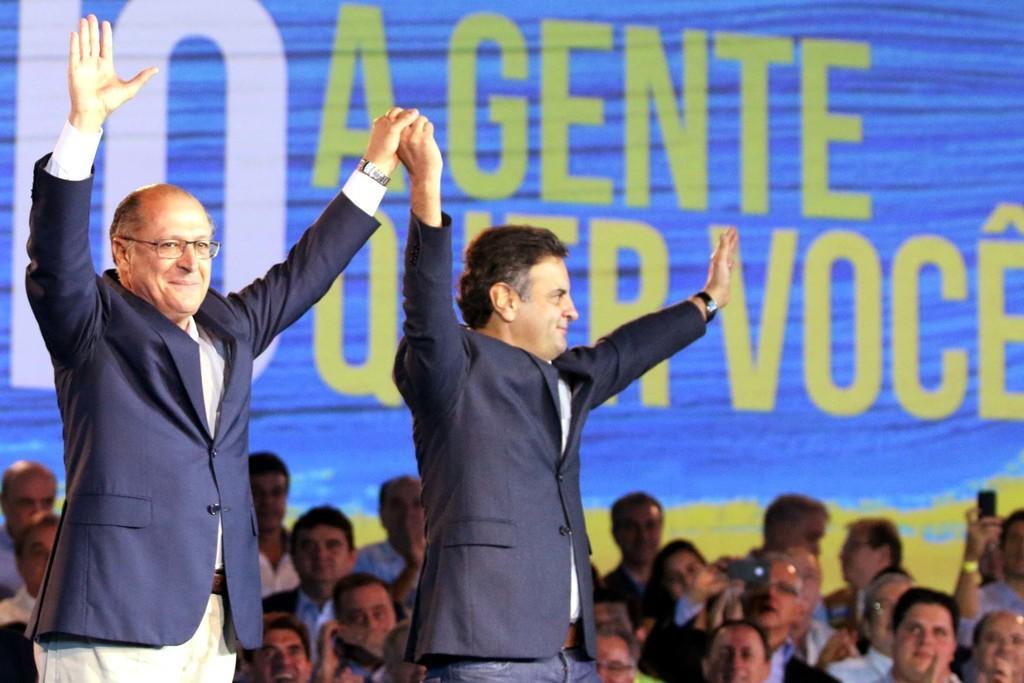Can you describe this image briefly? In this image, we can see persons wearing clothes. There are two persons in the middle of the image holding hands. In the background of the image, we can see some text. 